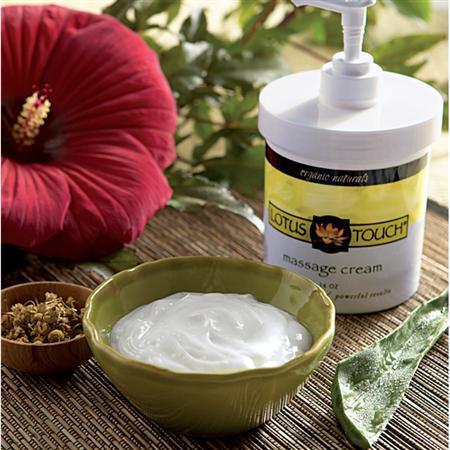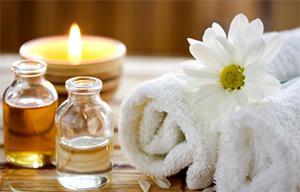The first image is the image on the left, the second image is the image on the right. Examine the images to the left and right. Is the description "There is a candle in one image." accurate? Answer yes or no. Yes. 